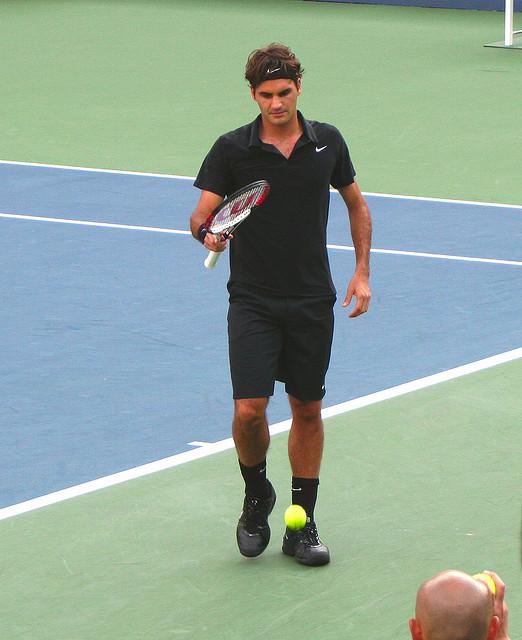Is the ball bouncing into his shorts?
Give a very brief answer. No. What color clothes is this person wearing?
Concise answer only. Black. Is this a grass tennis court?
Quick response, please. No. Is he wearing a headband?
Concise answer only. Yes. Why is a person behind the server?
Quick response, please. Catch balls. 